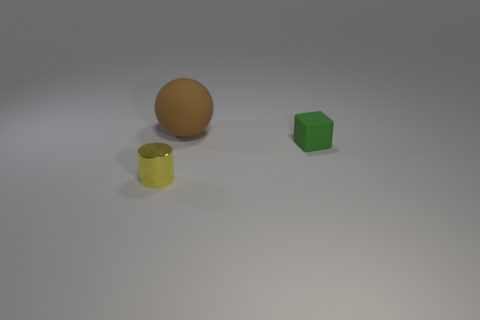What can you infer about the material and texture of these objects? Based on their appearance, the brown ball has a smooth texture with a somewhat shiny surface suggesting it might be made of a polished wood or plastic. The yellow cylindrical object appears to have a matte finish, possibly made of ceramic or plastic given its slight translucency. Lastly, the green hexahedral object also seems to have a matte texture, which could be indicative of a dense plastic material or maybe a type of synthetic ceramic. 